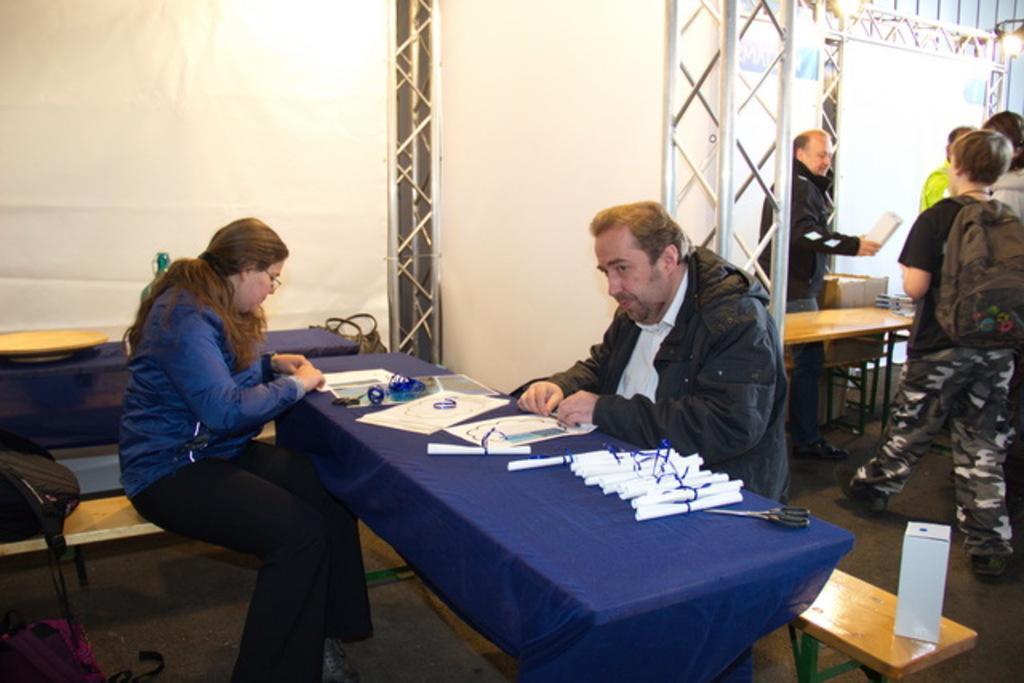Could you give a brief overview of what you see in this image? There are group of men standing at one side wearing backpacks. On the other side there is a man and woman sitting with tables and papers on it. 